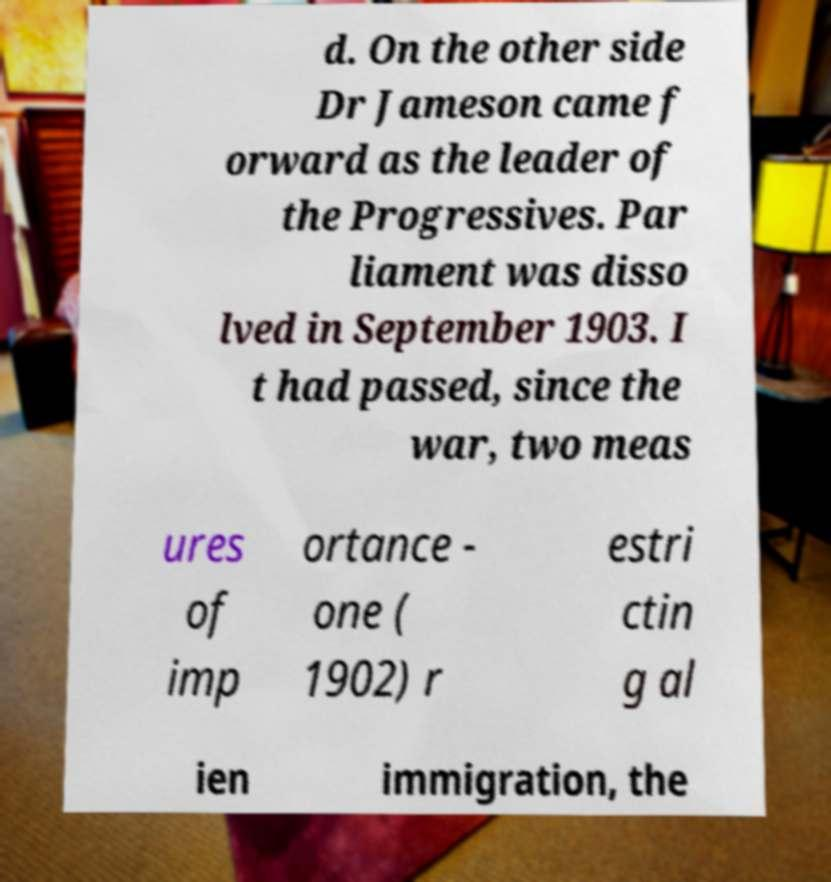For documentation purposes, I need the text within this image transcribed. Could you provide that? d. On the other side Dr Jameson came f orward as the leader of the Progressives. Par liament was disso lved in September 1903. I t had passed, since the war, two meas ures of imp ortance - one ( 1902) r estri ctin g al ien immigration, the 